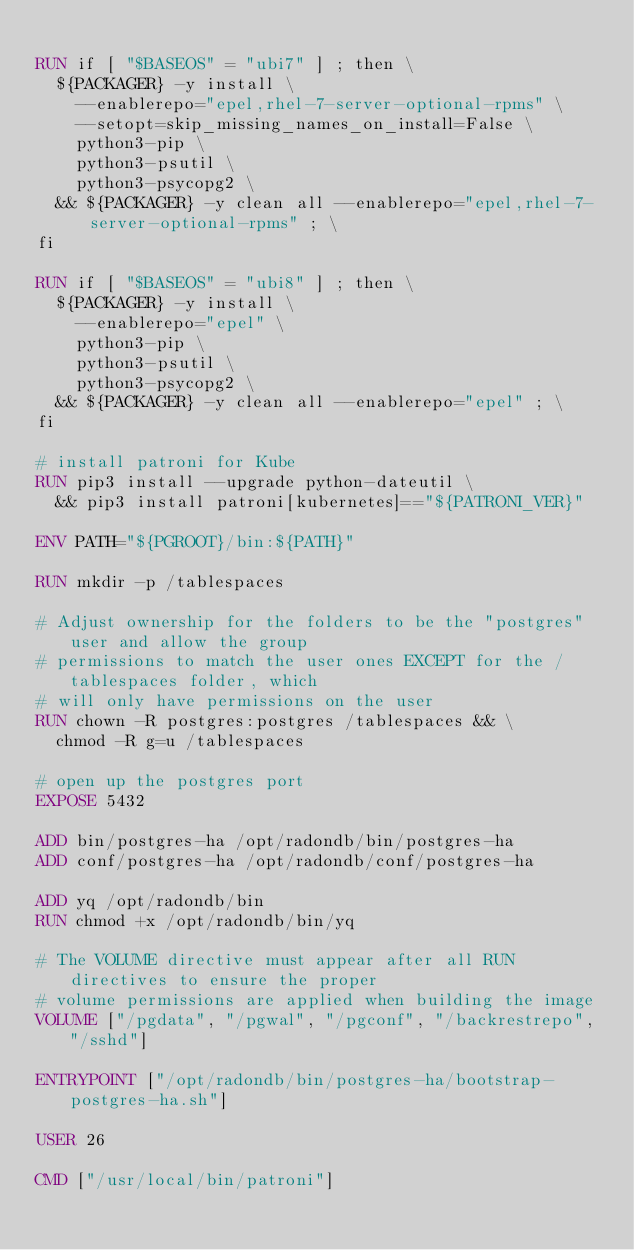<code> <loc_0><loc_0><loc_500><loc_500><_Dockerfile_>
RUN if [ "$BASEOS" = "ubi7" ] ; then \
	${PACKAGER} -y install \
		--enablerepo="epel,rhel-7-server-optional-rpms" \
		--setopt=skip_missing_names_on_install=False \
		python3-pip \
		python3-psutil \
		python3-psycopg2 \
	&& ${PACKAGER} -y clean all --enablerepo="epel,rhel-7-server-optional-rpms" ; \
fi

RUN if [ "$BASEOS" = "ubi8" ] ; then \
	${PACKAGER} -y install \
		--enablerepo="epel" \
		python3-pip \
		python3-psutil \
		python3-psycopg2 \
	&& ${PACKAGER} -y clean all --enablerepo="epel" ; \
fi

# install patroni for Kube
RUN pip3 install --upgrade python-dateutil \
	&& pip3 install patroni[kubernetes]=="${PATRONI_VER}"

ENV PATH="${PGROOT}/bin:${PATH}"

RUN mkdir -p /tablespaces

# Adjust ownership for the folders to be the "postgres" user and allow the group
# permissions to match the user ones EXCEPT for the /tablespaces folder, which
# will only have permissions on the user
RUN chown -R postgres:postgres /tablespaces && \
	chmod -R g=u /tablespaces

# open up the postgres port
EXPOSE 5432

ADD bin/postgres-ha /opt/radondb/bin/postgres-ha
ADD conf/postgres-ha /opt/radondb/conf/postgres-ha

ADD yq /opt/radondb/bin
RUN chmod +x /opt/radondb/bin/yq

# The VOLUME directive must appear after all RUN directives to ensure the proper
# volume permissions are applied when building the image
VOLUME ["/pgdata", "/pgwal", "/pgconf", "/backrestrepo", "/sshd"]

ENTRYPOINT ["/opt/radondb/bin/postgres-ha/bootstrap-postgres-ha.sh"]

USER 26

CMD ["/usr/local/bin/patroni"]
</code> 